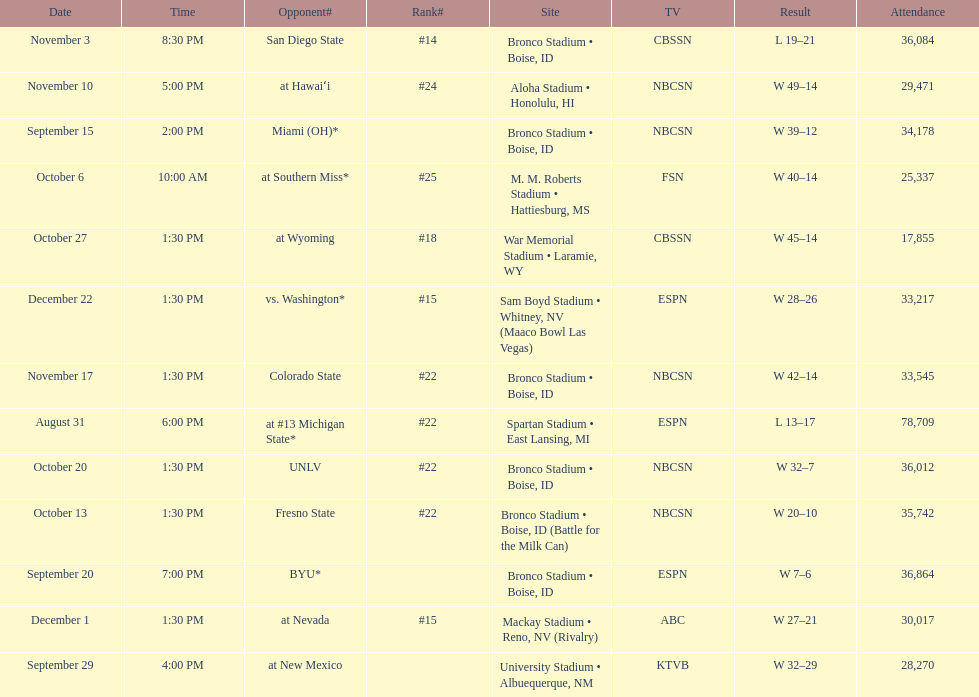What rank was boise state after november 10th? #22. 